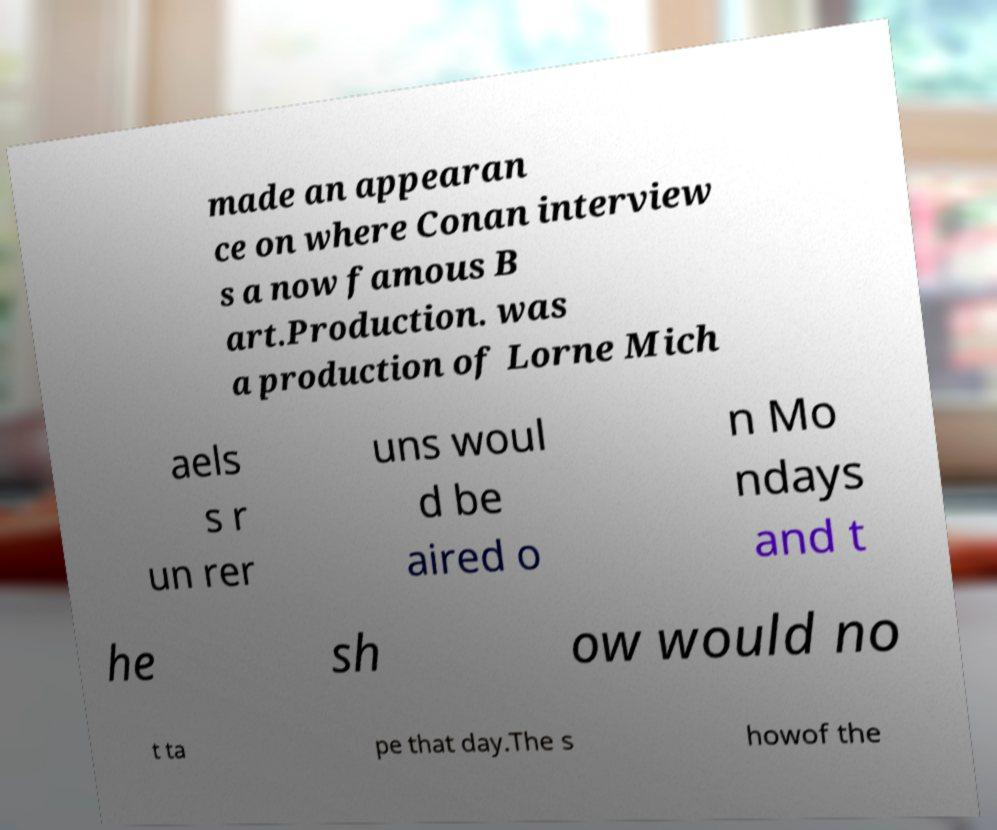Can you read and provide the text displayed in the image?This photo seems to have some interesting text. Can you extract and type it out for me? made an appearan ce on where Conan interview s a now famous B art.Production. was a production of Lorne Mich aels s r un rer uns woul d be aired o n Mo ndays and t he sh ow would no t ta pe that day.The s howof the 